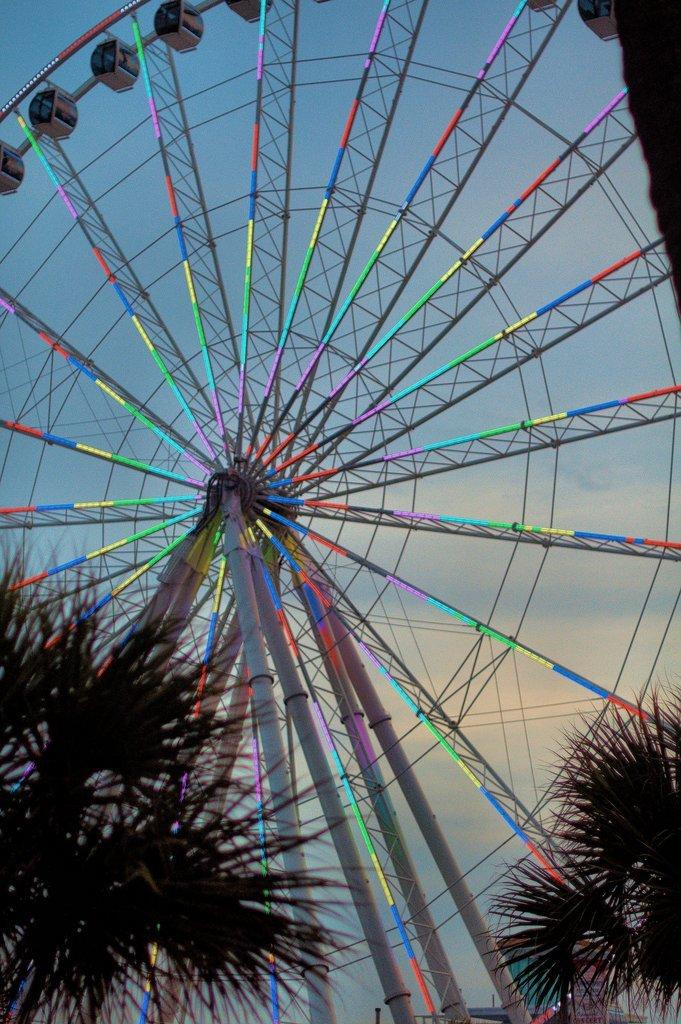What type of wheel is shown in the image? There is a joint wheel in the image. What else can be seen in the image besides the wheel? There are poles and plants visible in the image. What is visible in the background of the image? The sky is visible in the background of the image. What type of earth can be seen in the image? There is no earth visible in the image; it is a joint wheel, poles, plants, and sky. Are there any gravestones or tombstones present in the image? There is no cemetery or any indication of a cemetery in the image. 